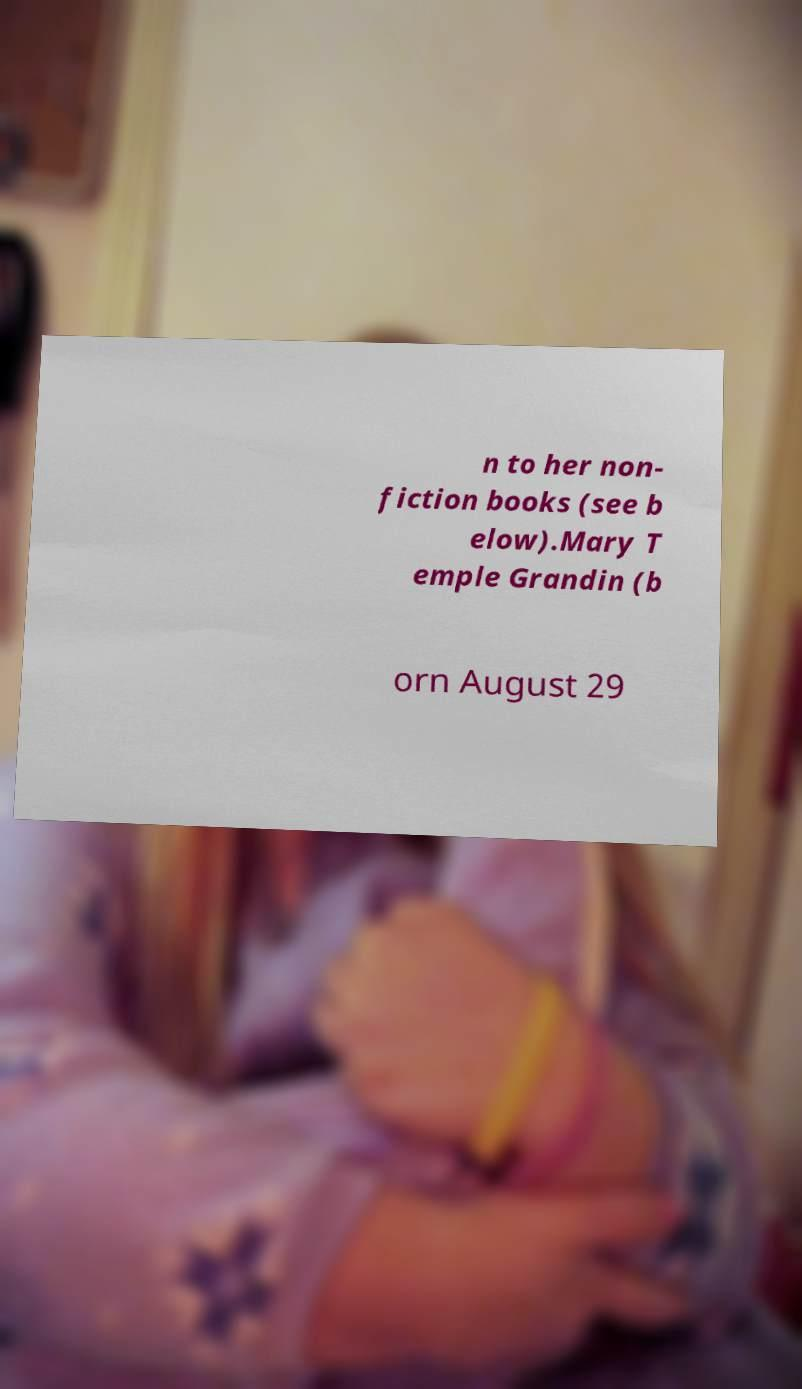Please identify and transcribe the text found in this image. n to her non- fiction books (see b elow).Mary T emple Grandin (b orn August 29 